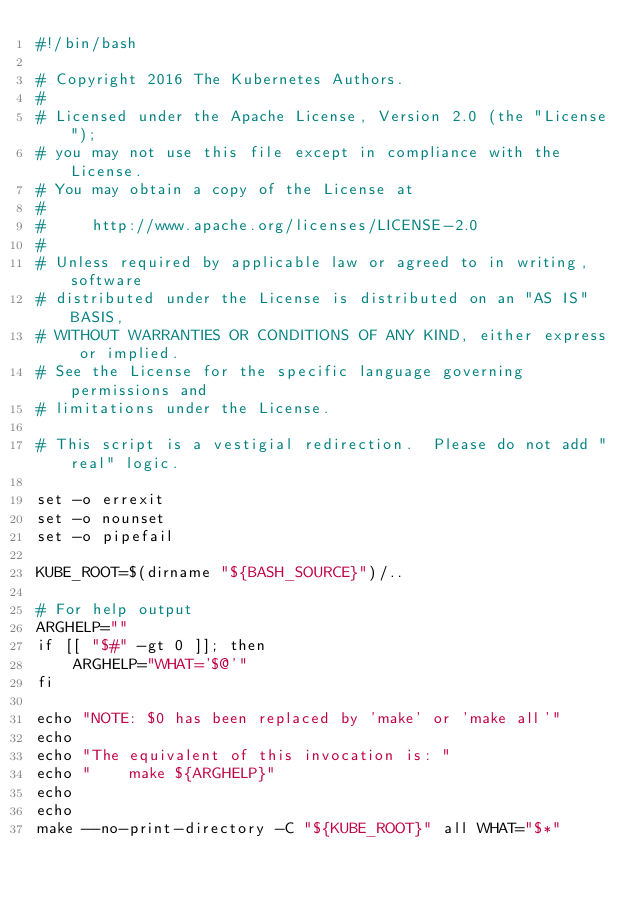<code> <loc_0><loc_0><loc_500><loc_500><_Bash_>#!/bin/bash

# Copyright 2016 The Kubernetes Authors.
#
# Licensed under the Apache License, Version 2.0 (the "License");
# you may not use this file except in compliance with the License.
# You may obtain a copy of the License at
#
#     http://www.apache.org/licenses/LICENSE-2.0
#
# Unless required by applicable law or agreed to in writing, software
# distributed under the License is distributed on an "AS IS" BASIS,
# WITHOUT WARRANTIES OR CONDITIONS OF ANY KIND, either express or implied.
# See the License for the specific language governing permissions and
# limitations under the License.

# This script is a vestigial redirection.  Please do not add "real" logic.

set -o errexit
set -o nounset
set -o pipefail

KUBE_ROOT=$(dirname "${BASH_SOURCE}")/..

# For help output
ARGHELP=""
if [[ "$#" -gt 0 ]]; then
    ARGHELP="WHAT='$@'"
fi

echo "NOTE: $0 has been replaced by 'make' or 'make all'"
echo
echo "The equivalent of this invocation is: "
echo "    make ${ARGHELP}"
echo
echo
make --no-print-directory -C "${KUBE_ROOT}" all WHAT="$*"
</code> 